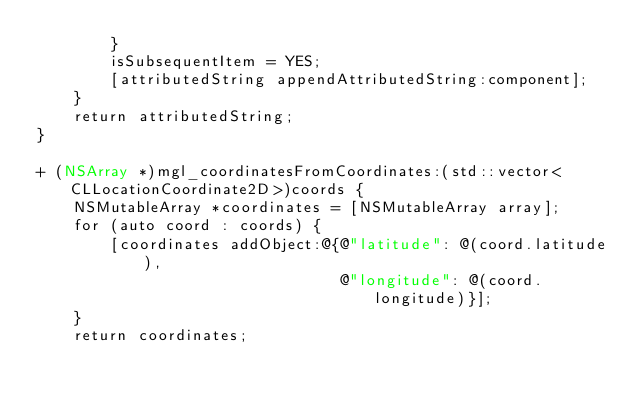<code> <loc_0><loc_0><loc_500><loc_500><_ObjectiveC_>        }
        isSubsequentItem = YES;
        [attributedString appendAttributedString:component];
    }
    return attributedString;
}

+ (NSArray *)mgl_coordinatesFromCoordinates:(std::vector<CLLocationCoordinate2D>)coords {
    NSMutableArray *coordinates = [NSMutableArray array];
    for (auto coord : coords) {
        [coordinates addObject:@{@"latitude": @(coord.latitude),
                                 @"longitude": @(coord.longitude)}];
    }
    return coordinates;</code> 